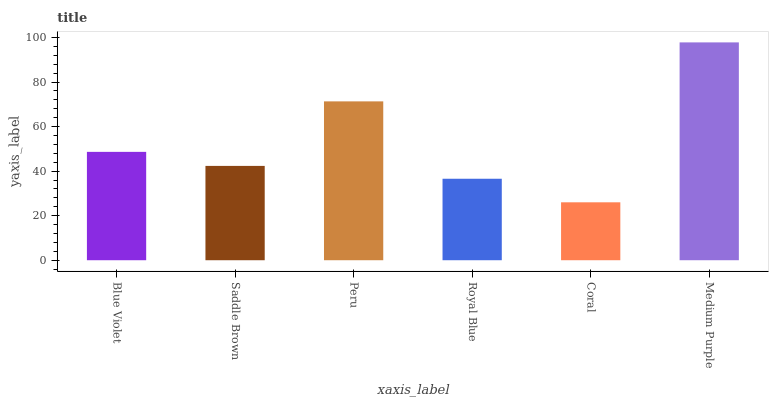Is Coral the minimum?
Answer yes or no. Yes. Is Medium Purple the maximum?
Answer yes or no. Yes. Is Saddle Brown the minimum?
Answer yes or no. No. Is Saddle Brown the maximum?
Answer yes or no. No. Is Blue Violet greater than Saddle Brown?
Answer yes or no. Yes. Is Saddle Brown less than Blue Violet?
Answer yes or no. Yes. Is Saddle Brown greater than Blue Violet?
Answer yes or no. No. Is Blue Violet less than Saddle Brown?
Answer yes or no. No. Is Blue Violet the high median?
Answer yes or no. Yes. Is Saddle Brown the low median?
Answer yes or no. Yes. Is Saddle Brown the high median?
Answer yes or no. No. Is Blue Violet the low median?
Answer yes or no. No. 